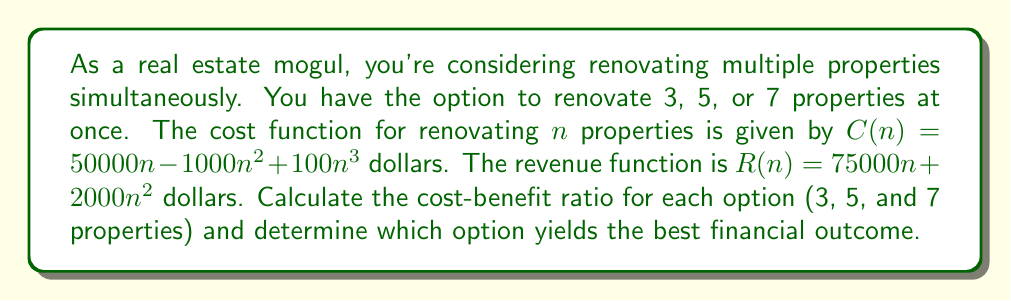Can you solve this math problem? To solve this problem, we need to follow these steps:

1. Calculate the cost for each option using the cost function $C(n)$.
2. Calculate the revenue for each option using the revenue function $R(n)$.
3. Calculate the profit for each option by subtracting the cost from the revenue.
4. Calculate the cost-benefit ratio for each option by dividing the revenue by the cost.
5. Compare the ratios to determine the best option.

Let's go through each step:

1. Calculating costs:
   For 3 properties: $C(3) = 50000(3) - 1000(3^2) + 100(3^3) = 150000 - 9000 + 2700 = 143700$
   For 5 properties: $C(5) = 50000(5) - 1000(5^2) + 100(5^3) = 250000 - 25000 + 12500 = 237500$
   For 7 properties: $C(7) = 50000(7) - 1000(7^2) + 100(7^3) = 350000 - 49000 + 34300 = 335300$

2. Calculating revenues:
   For 3 properties: $R(3) = 75000(3) + 2000(3^2) = 225000 + 18000 = 243000$
   For 5 properties: $R(5) = 75000(5) + 2000(5^2) = 375000 + 50000 = 425000$
   For 7 properties: $R(7) = 75000(7) + 2000(7^2) = 525000 + 98000 = 623000$

3. Calculating profits:
   For 3 properties: $243000 - 143700 = 99300$
   For 5 properties: $425000 - 237500 = 187500$
   For 7 properties: $623000 - 335300 = 287700$

4. Calculating cost-benefit ratios:
   For 3 properties: $\frac{243000}{143700} \approx 1.69$
   For 5 properties: $\frac{425000}{237500} \approx 1.79$
   For 7 properties: $\frac{623000}{335300} \approx 1.86$

5. Comparing ratios:
   The cost-benefit ratio increases as the number of properties increases, with 7 properties yielding the highest ratio of 1.86.
Answer: The cost-benefit ratios for renovating 3, 5, and 7 properties are approximately 1.69, 1.79, and 1.86, respectively. The option to renovate 7 properties simultaneously yields the best financial outcome with the highest cost-benefit ratio of 1.86. 